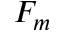<formula> <loc_0><loc_0><loc_500><loc_500>F _ { m }</formula> 